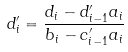<formula> <loc_0><loc_0><loc_500><loc_500>d _ { i } ^ { \prime } = \frac { d _ { i } - d _ { i - 1 } ^ { \prime } a _ { i } } { b _ { i } - c _ { i - 1 } ^ { \prime } a _ { i } }</formula> 